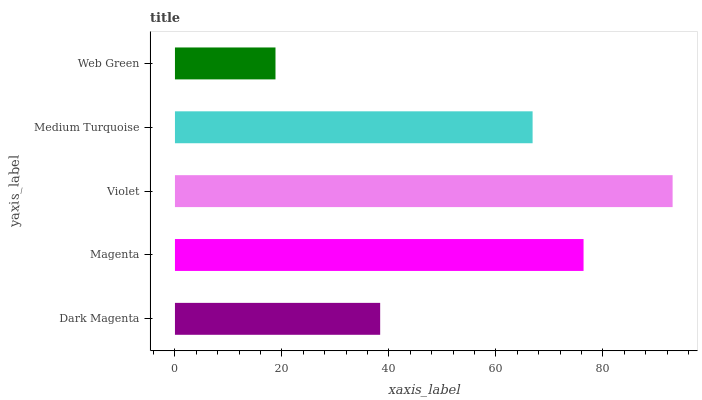Is Web Green the minimum?
Answer yes or no. Yes. Is Violet the maximum?
Answer yes or no. Yes. Is Magenta the minimum?
Answer yes or no. No. Is Magenta the maximum?
Answer yes or no. No. Is Magenta greater than Dark Magenta?
Answer yes or no. Yes. Is Dark Magenta less than Magenta?
Answer yes or no. Yes. Is Dark Magenta greater than Magenta?
Answer yes or no. No. Is Magenta less than Dark Magenta?
Answer yes or no. No. Is Medium Turquoise the high median?
Answer yes or no. Yes. Is Medium Turquoise the low median?
Answer yes or no. Yes. Is Web Green the high median?
Answer yes or no. No. Is Dark Magenta the low median?
Answer yes or no. No. 